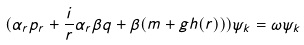Convert formula to latex. <formula><loc_0><loc_0><loc_500><loc_500>( \alpha _ { r } p _ { r } + \frac { i } { r } \alpha _ { r } \beta q + \beta ( m + g h ( r ) ) ) \psi _ { k } = \omega \psi _ { k }</formula> 